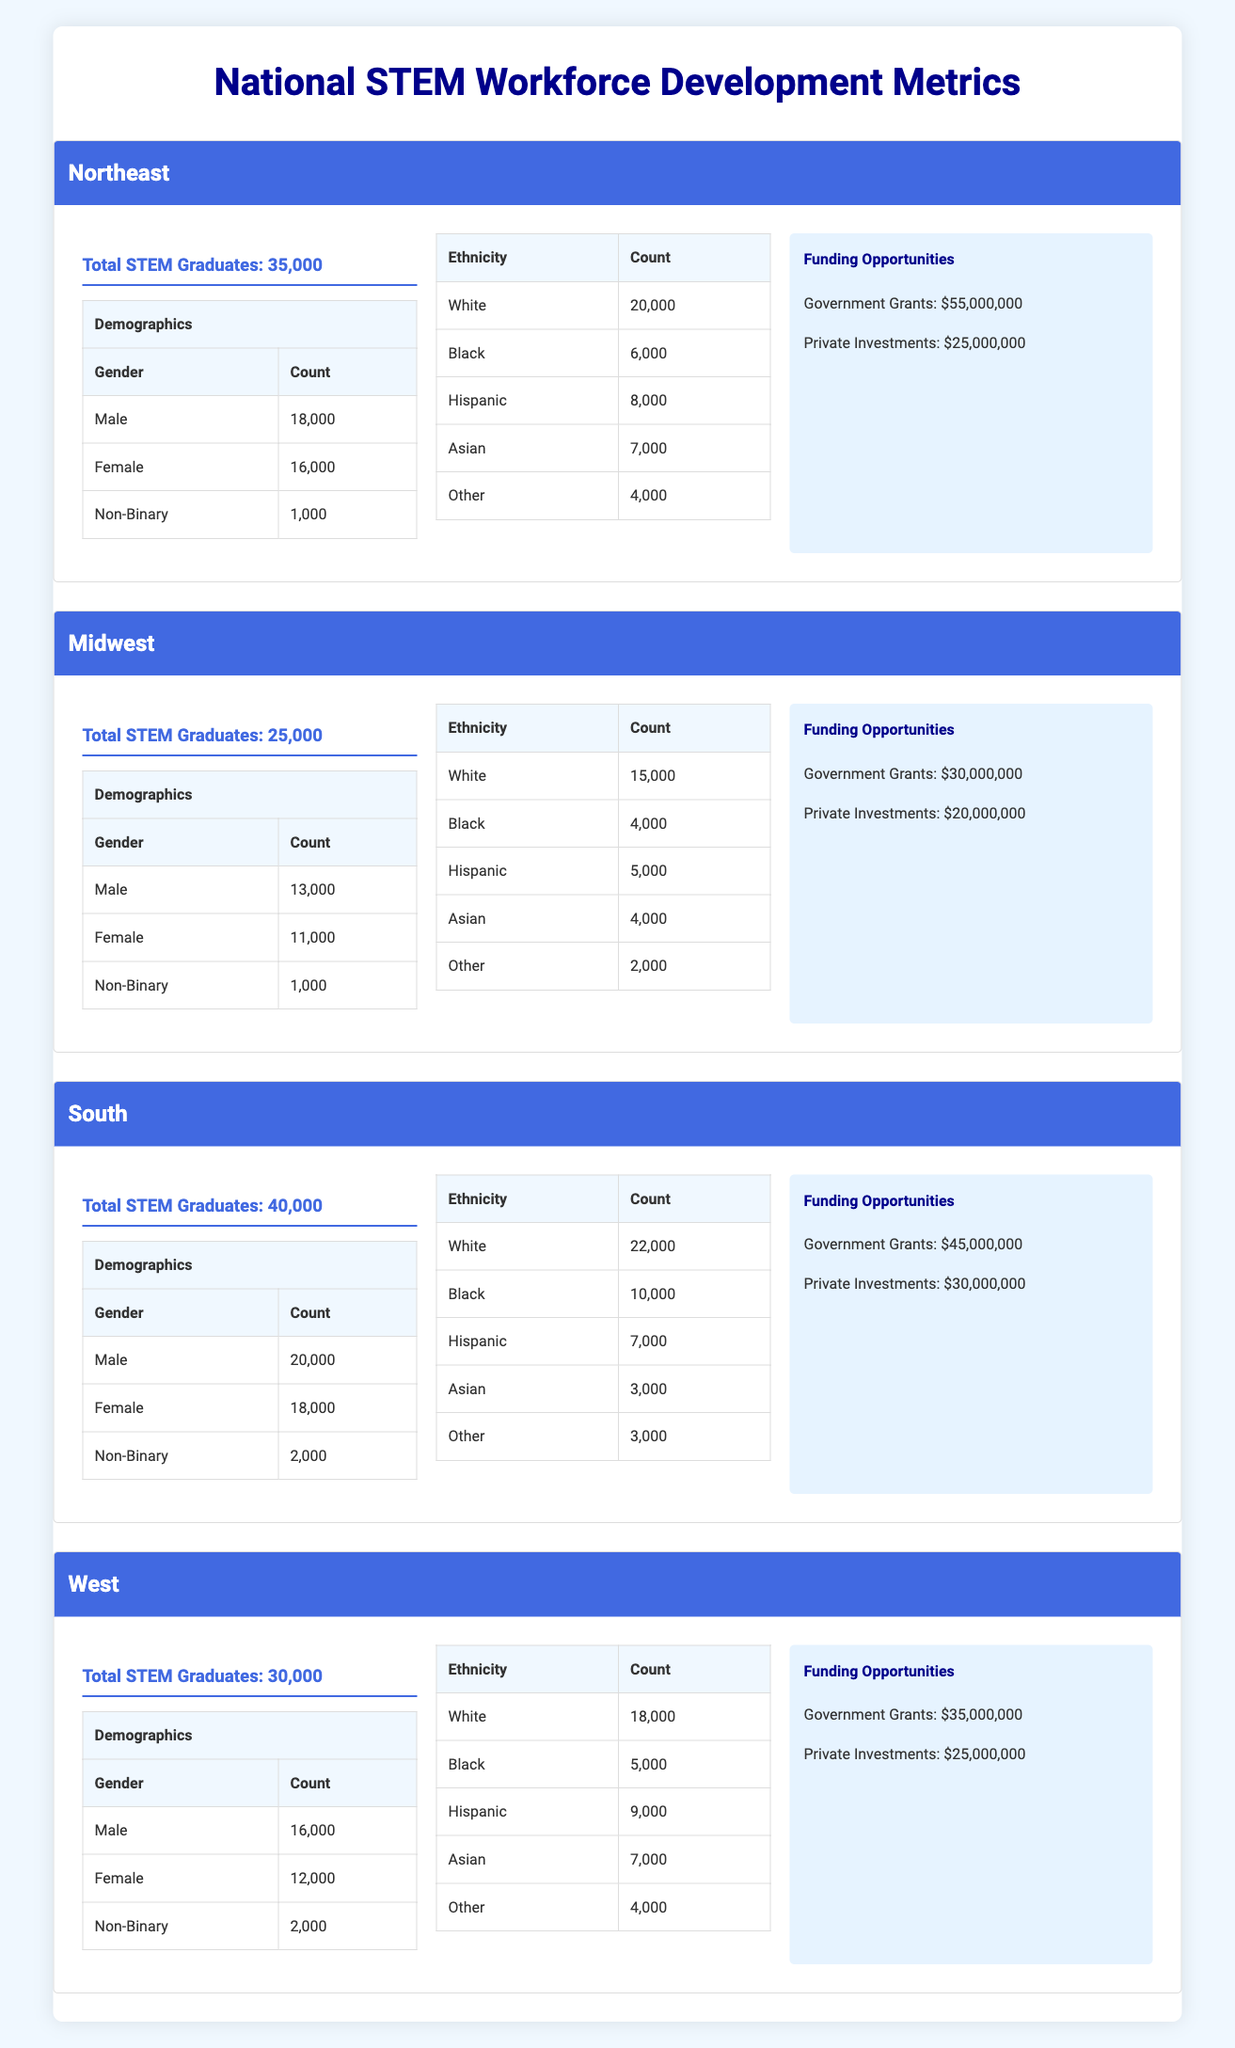What is the total number of STEM graduates in the South? According to the table, the South has a total of 40,000 STEM graduates listed.
Answer: 40,000 Which region has the highest number of male STEM graduates? The Northeast has 18,000 male STEM graduates, the South has 20,000, the Midwest has 13,000, and the West has 16,000. Therefore, the South has the highest number of male STEM graduates.
Answer: South How many non-binary STEM graduates are there across all regions combined? The Northeast has 1,000, the Midwest has 1,000, the South has 2,000, and the West has 2,000. Therefore, the total is 1,000 + 1,000 + 2,000 + 2,000 = 6,000.
Answer: 6,000 Is the percentage of female STEM graduates in the Midwest greater than that in the Northeast? The Midwest has 11,000 female graduates out of 25,000 total, which is 44%. The Northeast has 16,000 female graduates out of 35,000 total, which is approximately 45.7%. Thus, the percentage of female graduates in the Midwest is less than that in the Northeast.
Answer: No What is the total funding opportunities (government grants and private investments) for the West region? For the West, government grants total $35,000,000 and private investments total $25,000,000. Adding these gives $35,000,000 + $25,000,000 = $60,000,000.
Answer: $60,000,000 Which ethnic group has the highest number of graduates in the South region? In the South, the White ethnic group has 22,000 graduates, while other ethnic groups have lower numbers: Black has 10,000, Hispanic 7,000, Asian 3,000, and Other 3,000. Hence, White has the highest number.
Answer: White What is the average number of male graduates across all regions? The male graduates are Northeast 18,000, Midwest 13,000, South 20,000, and West 16,000. Adding these gives 18,000 + 13,000 + 20,000 + 16,000 = 67,000. There are 4 regions, so the average is 67,000 / 4 = 16,750.
Answer: 16,750 True or False: The total number of government grants in the Midwest is less than that in the South. The Midwest has $30,000,000 in government grants, whereas the South has $45,000,000. Since $30,000,000 is less than $45,000,000, the statement is true.
Answer: True What is the total number of female graduates in the Northeast and the West combined? The Northeast has 16,000 female graduates, and the West has 12,000. Adding these numbers gives 16,000 + 12,000 = 28,000.
Answer: 28,000 